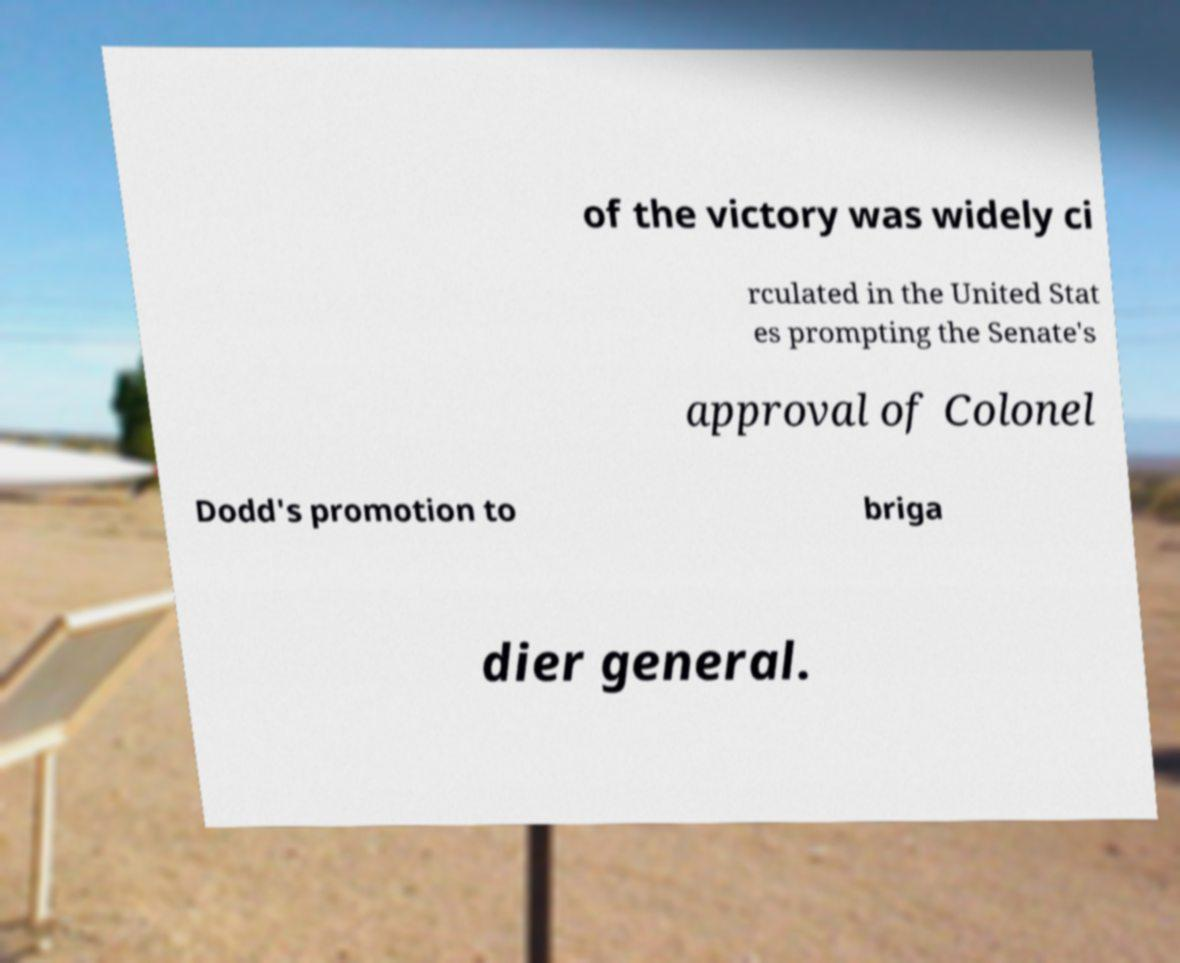There's text embedded in this image that I need extracted. Can you transcribe it verbatim? of the victory was widely ci rculated in the United Stat es prompting the Senate's approval of Colonel Dodd's promotion to briga dier general. 